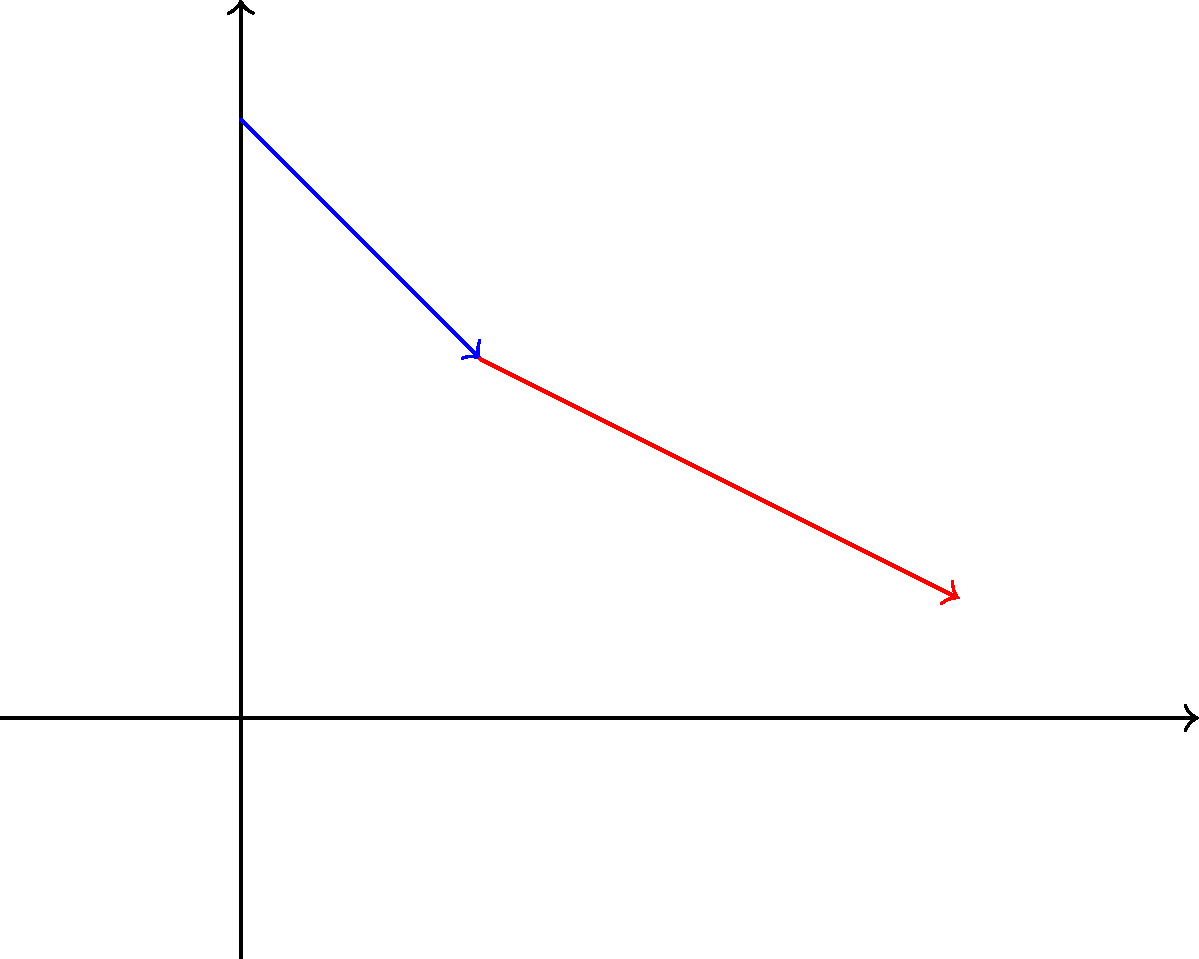In your historical drama set in the 17th century, you want to accurately depict the refraction of light through a glass prism, similar to Isaac Newton's experiments. A light ray travels from air ($n_1 = 1.00$) into a glass prism ($n_2 = 1.52$) at an angle of incidence $\theta_1 = 45°$. Using Snell's law, calculate the angle of refraction $\theta_2$ inside the glass prism. To solve this problem, we'll use Snell's law and follow these steps:

1. Recall Snell's law: $n_1 \sin(\theta_1) = n_2 \sin(\theta_2)$

2. We know the following values:
   $n_1 = 1.00$ (refractive index of air)
   $n_2 = 1.52$ (refractive index of glass)
   $\theta_1 = 45°$ (angle of incidence)

3. Substitute these values into Snell's law:
   $1.00 \sin(45°) = 1.52 \sin(\theta_2)$

4. Simplify the left side:
   $\sin(45°) = 1.52 \sin(\theta_2)$
   $\frac{\sqrt{2}}{2} = 1.52 \sin(\theta_2)$

5. Solve for $\sin(\theta_2)$:
   $\sin(\theta_2) = \frac{\sqrt{2}}{2 \cdot 1.52} \approx 0.4634$

6. Take the inverse sine (arcsin) of both sides to find $\theta_2$:
   $\theta_2 = \arcsin(0.4634) \approx 27.57°$

7. Round to two decimal places:
   $\theta_2 \approx 27.57°$
Answer: $27.57°$ 